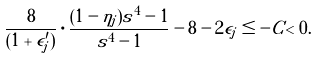<formula> <loc_0><loc_0><loc_500><loc_500>\frac { 8 } { ( 1 + \epsilon _ { j } ^ { \prime } ) } \cdot \frac { ( 1 - \eta _ { j } ) s ^ { 4 } - 1 } { s ^ { 4 } - 1 } - 8 - 2 \epsilon _ { j } \leq - C < 0 .</formula> 